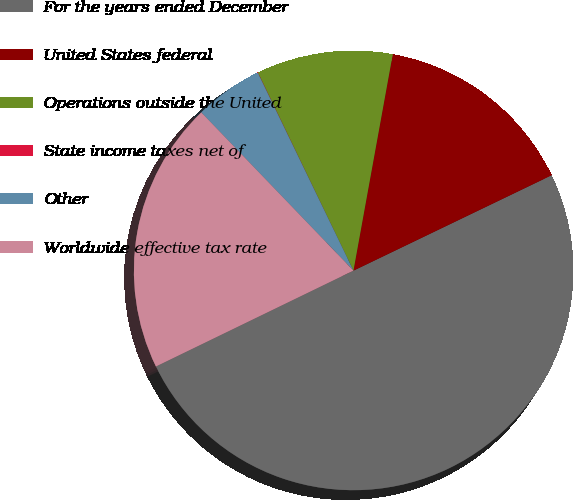Convert chart to OTSL. <chart><loc_0><loc_0><loc_500><loc_500><pie_chart><fcel>For the years ended December<fcel>United States federal<fcel>Operations outside the United<fcel>State income taxes net of<fcel>Other<fcel>Worldwide effective tax rate<nl><fcel>49.95%<fcel>15.0%<fcel>10.01%<fcel>0.02%<fcel>5.02%<fcel>20.0%<nl></chart> 